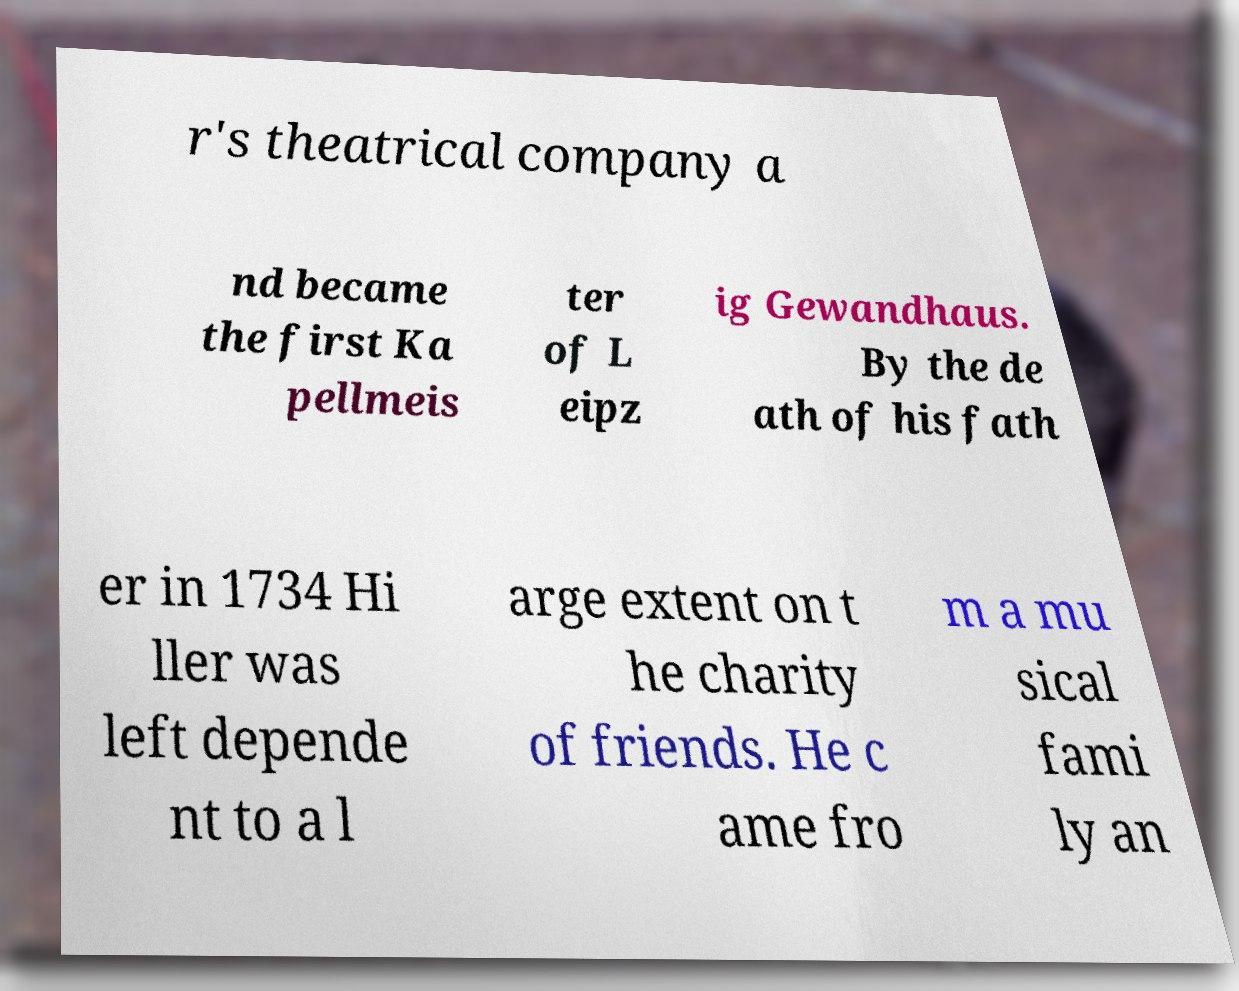There's text embedded in this image that I need extracted. Can you transcribe it verbatim? r's theatrical company a nd became the first Ka pellmeis ter of L eipz ig Gewandhaus. By the de ath of his fath er in 1734 Hi ller was left depende nt to a l arge extent on t he charity of friends. He c ame fro m a mu sical fami ly an 